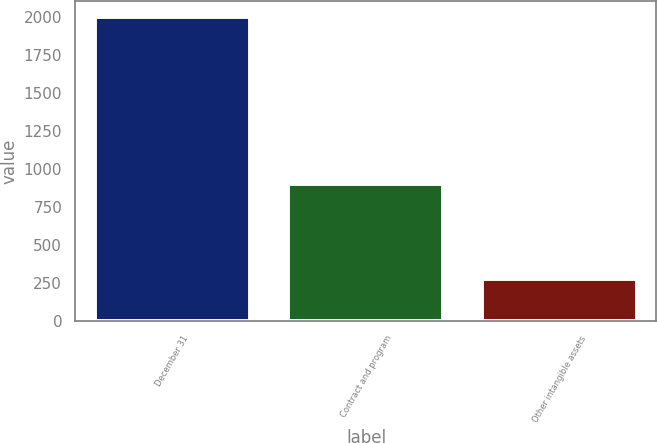<chart> <loc_0><loc_0><loc_500><loc_500><bar_chart><fcel>December 31<fcel>Contract and program<fcel>Other intangible assets<nl><fcel>2003<fcel>900<fcel>278<nl></chart> 